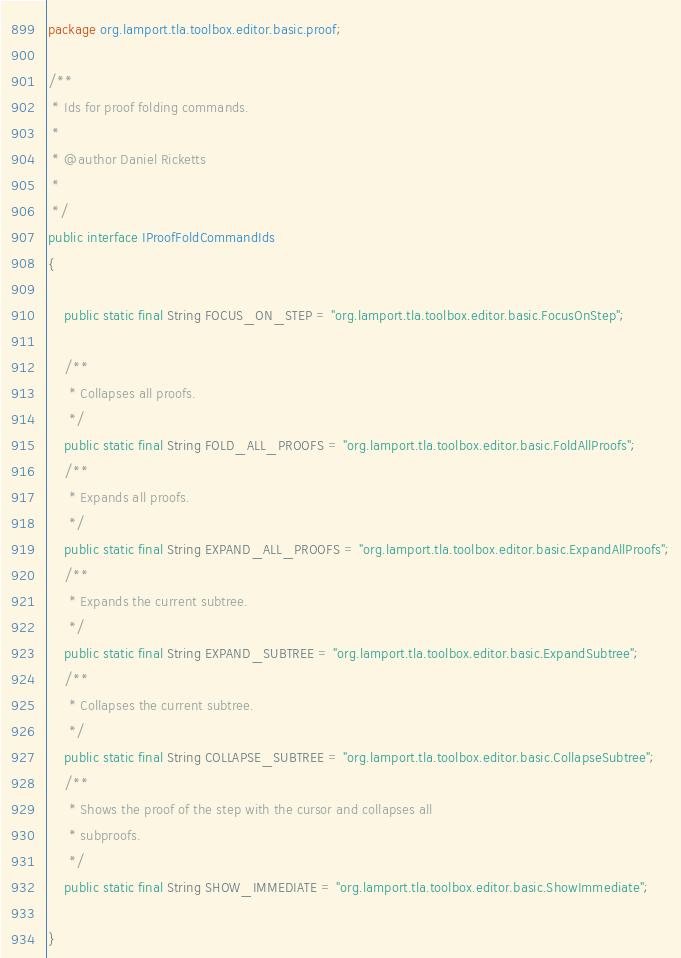<code> <loc_0><loc_0><loc_500><loc_500><_Java_>package org.lamport.tla.toolbox.editor.basic.proof;

/**
 * Ids for proof folding commands.
 * 
 * @author Daniel Ricketts
 *
 */
public interface IProofFoldCommandIds
{

    public static final String FOCUS_ON_STEP = "org.lamport.tla.toolbox.editor.basic.FocusOnStep";

    /**
     * Collapses all proofs.
     */
    public static final String FOLD_ALL_PROOFS = "org.lamport.tla.toolbox.editor.basic.FoldAllProofs";
    /**
     * Expands all proofs.
     */
    public static final String EXPAND_ALL_PROOFS = "org.lamport.tla.toolbox.editor.basic.ExpandAllProofs";
    /**
     * Expands the current subtree.
     */
    public static final String EXPAND_SUBTREE = "org.lamport.tla.toolbox.editor.basic.ExpandSubtree";
    /**
     * Collapses the current subtree.
     */
    public static final String COLLAPSE_SUBTREE = "org.lamport.tla.toolbox.editor.basic.CollapseSubtree";
    /**
     * Shows the proof of the step with the cursor and collapses all
     * subproofs.
     */
    public static final String SHOW_IMMEDIATE = "org.lamport.tla.toolbox.editor.basic.ShowImmediate";

}
</code> 